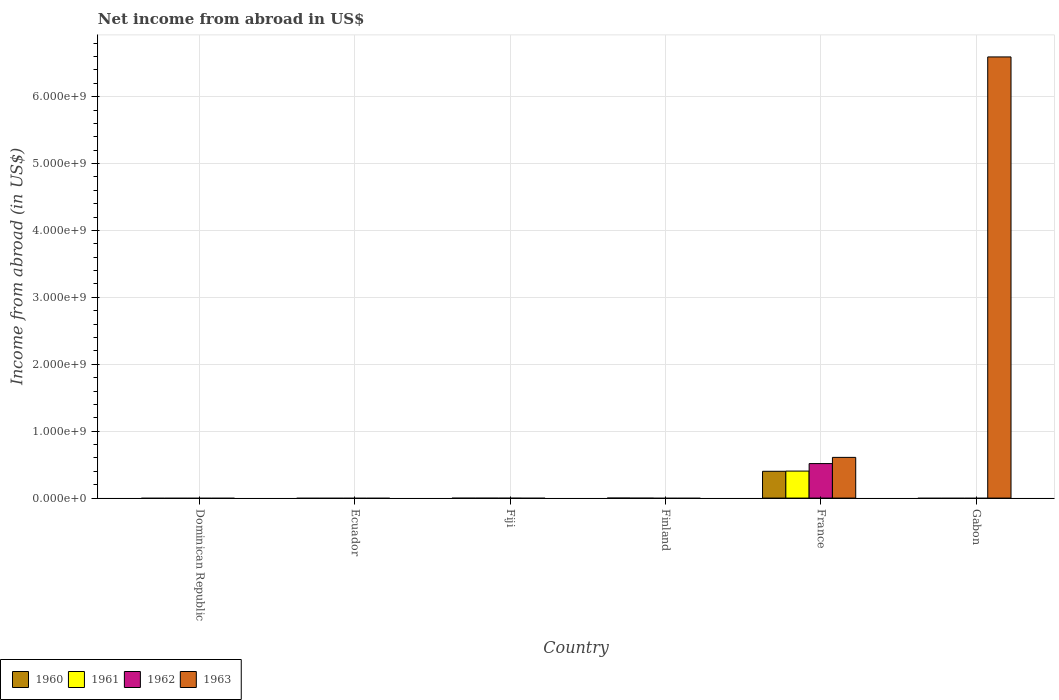Are the number of bars per tick equal to the number of legend labels?
Make the answer very short. No. Are the number of bars on each tick of the X-axis equal?
Give a very brief answer. No. How many bars are there on the 5th tick from the left?
Give a very brief answer. 4. How many bars are there on the 2nd tick from the right?
Provide a short and direct response. 4. What is the label of the 3rd group of bars from the left?
Provide a short and direct response. Fiji. What is the net income from abroad in 1961 in Finland?
Ensure brevity in your answer.  0. Across all countries, what is the maximum net income from abroad in 1962?
Keep it short and to the point. 5.16e+08. Across all countries, what is the minimum net income from abroad in 1960?
Offer a terse response. 0. What is the total net income from abroad in 1963 in the graph?
Make the answer very short. 7.20e+09. What is the average net income from abroad in 1961 per country?
Your answer should be very brief. 6.73e+07. What is the difference between the net income from abroad of/in 1962 and net income from abroad of/in 1963 in France?
Make the answer very short. -9.27e+07. What is the difference between the highest and the lowest net income from abroad in 1961?
Your answer should be very brief. 4.04e+08. In how many countries, is the net income from abroad in 1963 greater than the average net income from abroad in 1963 taken over all countries?
Provide a short and direct response. 1. Is it the case that in every country, the sum of the net income from abroad in 1963 and net income from abroad in 1962 is greater than the sum of net income from abroad in 1960 and net income from abroad in 1961?
Give a very brief answer. No. How many bars are there?
Offer a terse response. 5. How many countries are there in the graph?
Provide a short and direct response. 6. Does the graph contain any zero values?
Offer a terse response. Yes. Where does the legend appear in the graph?
Give a very brief answer. Bottom left. How are the legend labels stacked?
Keep it short and to the point. Horizontal. What is the title of the graph?
Provide a succinct answer. Net income from abroad in US$. What is the label or title of the X-axis?
Ensure brevity in your answer.  Country. What is the label or title of the Y-axis?
Make the answer very short. Income from abroad (in US$). What is the Income from abroad (in US$) of 1961 in Dominican Republic?
Offer a very short reply. 0. What is the Income from abroad (in US$) of 1963 in Dominican Republic?
Your answer should be very brief. 0. What is the Income from abroad (in US$) in 1962 in Ecuador?
Ensure brevity in your answer.  0. What is the Income from abroad (in US$) in 1961 in Fiji?
Give a very brief answer. 0. What is the Income from abroad (in US$) in 1962 in Fiji?
Keep it short and to the point. 0. What is the Income from abroad (in US$) of 1961 in Finland?
Your answer should be very brief. 0. What is the Income from abroad (in US$) in 1963 in Finland?
Give a very brief answer. 0. What is the Income from abroad (in US$) of 1960 in France?
Keep it short and to the point. 4.01e+08. What is the Income from abroad (in US$) of 1961 in France?
Provide a short and direct response. 4.04e+08. What is the Income from abroad (in US$) of 1962 in France?
Your response must be concise. 5.16e+08. What is the Income from abroad (in US$) of 1963 in France?
Offer a very short reply. 6.08e+08. What is the Income from abroad (in US$) in 1961 in Gabon?
Give a very brief answer. 0. What is the Income from abroad (in US$) in 1962 in Gabon?
Give a very brief answer. 0. What is the Income from abroad (in US$) in 1963 in Gabon?
Give a very brief answer. 6.59e+09. Across all countries, what is the maximum Income from abroad (in US$) of 1960?
Offer a very short reply. 4.01e+08. Across all countries, what is the maximum Income from abroad (in US$) in 1961?
Your answer should be very brief. 4.04e+08. Across all countries, what is the maximum Income from abroad (in US$) in 1962?
Offer a very short reply. 5.16e+08. Across all countries, what is the maximum Income from abroad (in US$) of 1963?
Your response must be concise. 6.59e+09. Across all countries, what is the minimum Income from abroad (in US$) in 1961?
Your answer should be compact. 0. What is the total Income from abroad (in US$) in 1960 in the graph?
Offer a very short reply. 4.01e+08. What is the total Income from abroad (in US$) of 1961 in the graph?
Keep it short and to the point. 4.04e+08. What is the total Income from abroad (in US$) in 1962 in the graph?
Offer a very short reply. 5.16e+08. What is the total Income from abroad (in US$) in 1963 in the graph?
Provide a succinct answer. 7.20e+09. What is the difference between the Income from abroad (in US$) of 1963 in France and that in Gabon?
Make the answer very short. -5.99e+09. What is the difference between the Income from abroad (in US$) in 1960 in France and the Income from abroad (in US$) in 1963 in Gabon?
Ensure brevity in your answer.  -6.19e+09. What is the difference between the Income from abroad (in US$) of 1961 in France and the Income from abroad (in US$) of 1963 in Gabon?
Your answer should be very brief. -6.19e+09. What is the difference between the Income from abroad (in US$) of 1962 in France and the Income from abroad (in US$) of 1963 in Gabon?
Offer a terse response. -6.08e+09. What is the average Income from abroad (in US$) of 1960 per country?
Your answer should be compact. 6.68e+07. What is the average Income from abroad (in US$) in 1961 per country?
Your answer should be very brief. 6.73e+07. What is the average Income from abroad (in US$) in 1962 per country?
Offer a very short reply. 8.60e+07. What is the average Income from abroad (in US$) of 1963 per country?
Offer a very short reply. 1.20e+09. What is the difference between the Income from abroad (in US$) of 1960 and Income from abroad (in US$) of 1961 in France?
Keep it short and to the point. -3.05e+06. What is the difference between the Income from abroad (in US$) of 1960 and Income from abroad (in US$) of 1962 in France?
Your response must be concise. -1.15e+08. What is the difference between the Income from abroad (in US$) in 1960 and Income from abroad (in US$) in 1963 in France?
Make the answer very short. -2.08e+08. What is the difference between the Income from abroad (in US$) of 1961 and Income from abroad (in US$) of 1962 in France?
Provide a short and direct response. -1.12e+08. What is the difference between the Income from abroad (in US$) of 1961 and Income from abroad (in US$) of 1963 in France?
Offer a terse response. -2.05e+08. What is the difference between the Income from abroad (in US$) in 1962 and Income from abroad (in US$) in 1963 in France?
Your response must be concise. -9.27e+07. What is the ratio of the Income from abroad (in US$) in 1963 in France to that in Gabon?
Make the answer very short. 0.09. What is the difference between the highest and the lowest Income from abroad (in US$) in 1960?
Your response must be concise. 4.01e+08. What is the difference between the highest and the lowest Income from abroad (in US$) of 1961?
Your answer should be compact. 4.04e+08. What is the difference between the highest and the lowest Income from abroad (in US$) in 1962?
Offer a very short reply. 5.16e+08. What is the difference between the highest and the lowest Income from abroad (in US$) of 1963?
Your response must be concise. 6.59e+09. 